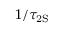Convert formula to latex. <formula><loc_0><loc_0><loc_500><loc_500>1 / \tau _ { 2 S }</formula> 